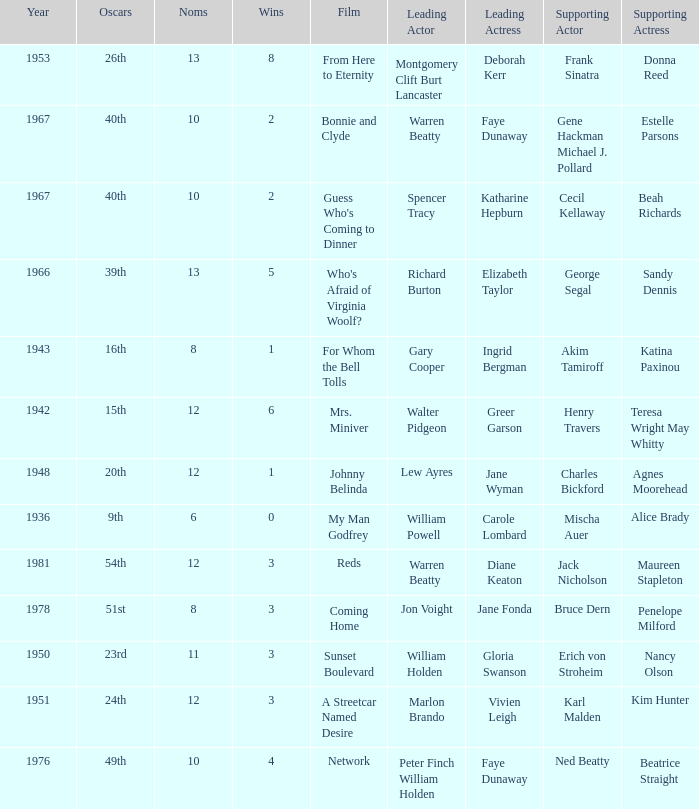Who was the supporting actress in a film with Diane Keaton as the leading actress? Maureen Stapleton. 